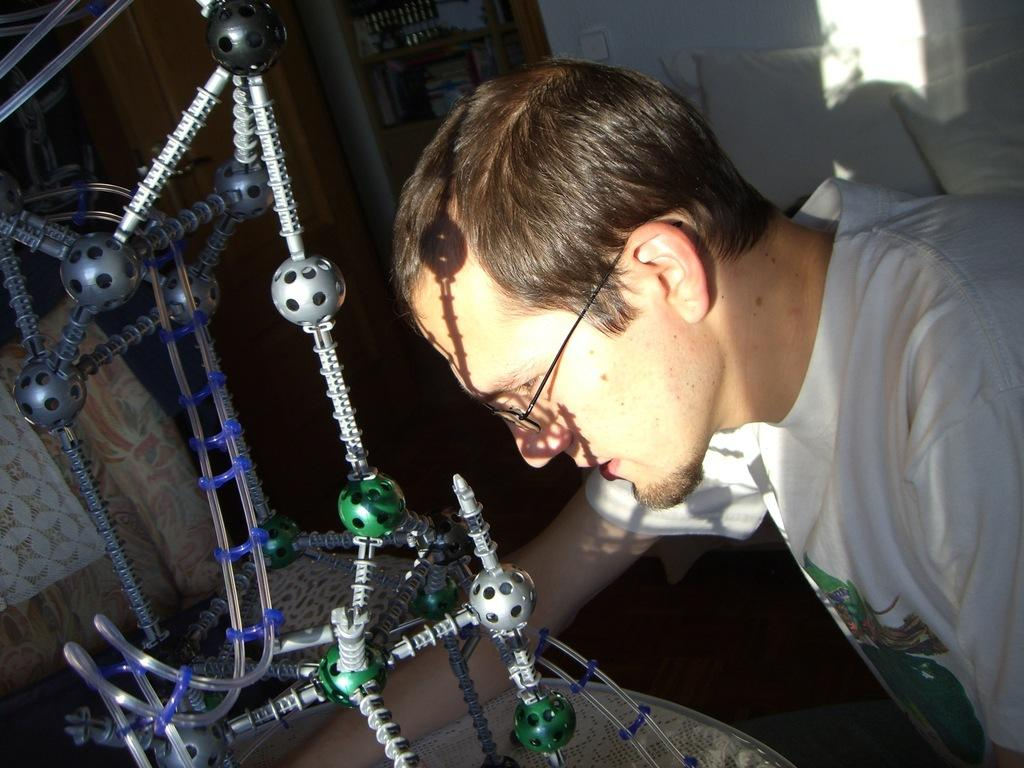What is the person wearing in the image? The person in the image is wearing a white t-shirt. What can be seen on the left side of the image? There is an instrument on the left side of the image. What type of furniture is present in the image? There is a chair in the image. What can be seen in the background of the image? There is a bookshelf, a door, a pillow, and a bed in the background of the image. What type of decision does the person in the image have to make regarding their debt? There is no mention of debt or any decision-making process in the image. 